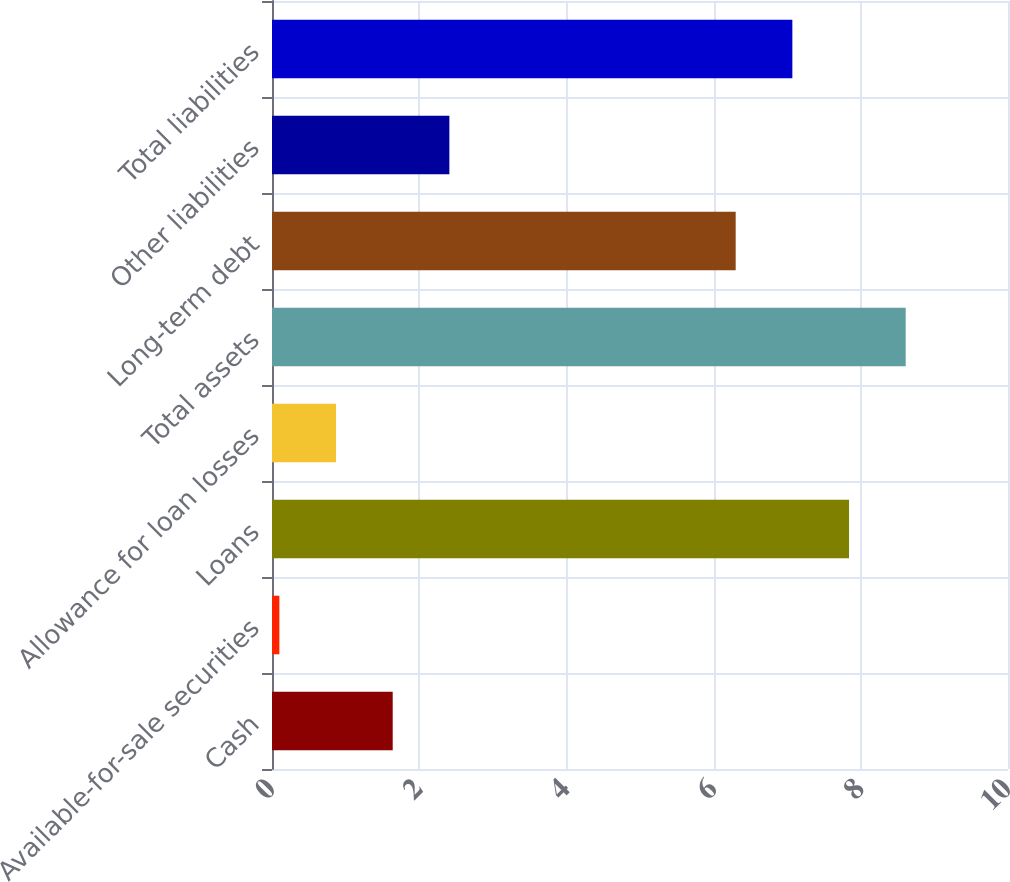Convert chart. <chart><loc_0><loc_0><loc_500><loc_500><bar_chart><fcel>Cash<fcel>Available-for-sale securities<fcel>Loans<fcel>Allowance for loan losses<fcel>Total assets<fcel>Long-term debt<fcel>Other liabilities<fcel>Total liabilities<nl><fcel>1.64<fcel>0.1<fcel>7.84<fcel>0.87<fcel>8.61<fcel>6.3<fcel>2.41<fcel>7.07<nl></chart> 